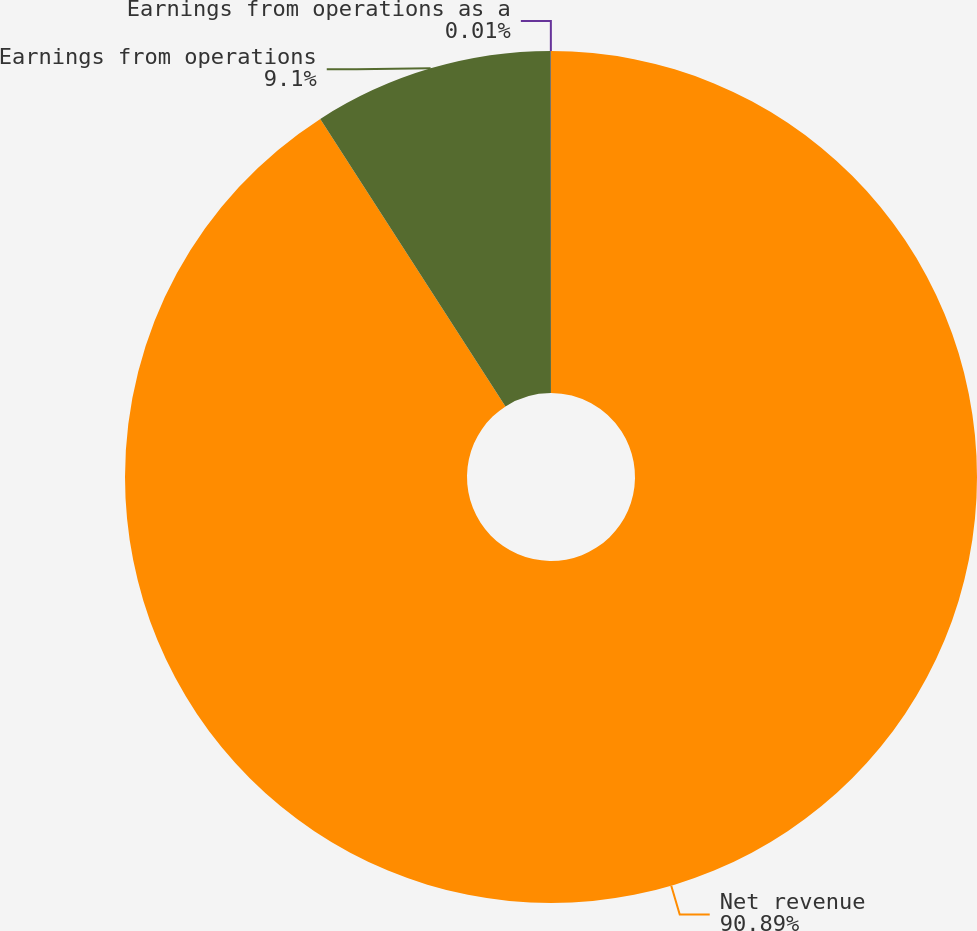<chart> <loc_0><loc_0><loc_500><loc_500><pie_chart><fcel>Net revenue<fcel>Earnings from operations<fcel>Earnings from operations as a<nl><fcel>90.89%<fcel>9.1%<fcel>0.01%<nl></chart> 